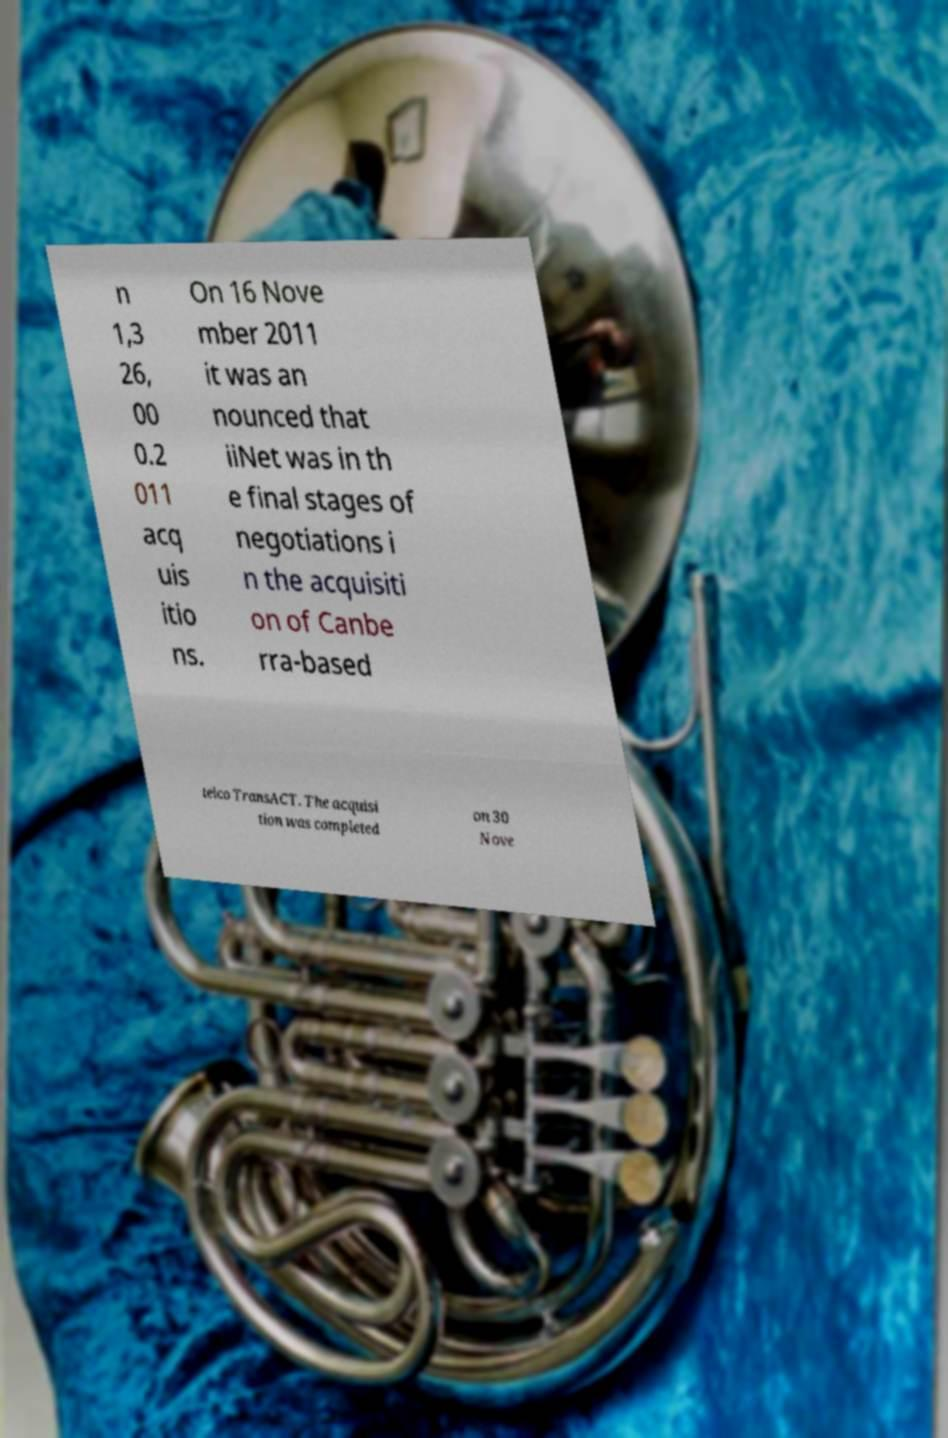What messages or text are displayed in this image? I need them in a readable, typed format. n 1,3 26, 00 0.2 011 acq uis itio ns. On 16 Nove mber 2011 it was an nounced that iiNet was in th e final stages of negotiations i n the acquisiti on of Canbe rra-based telco TransACT. The acquisi tion was completed on 30 Nove 